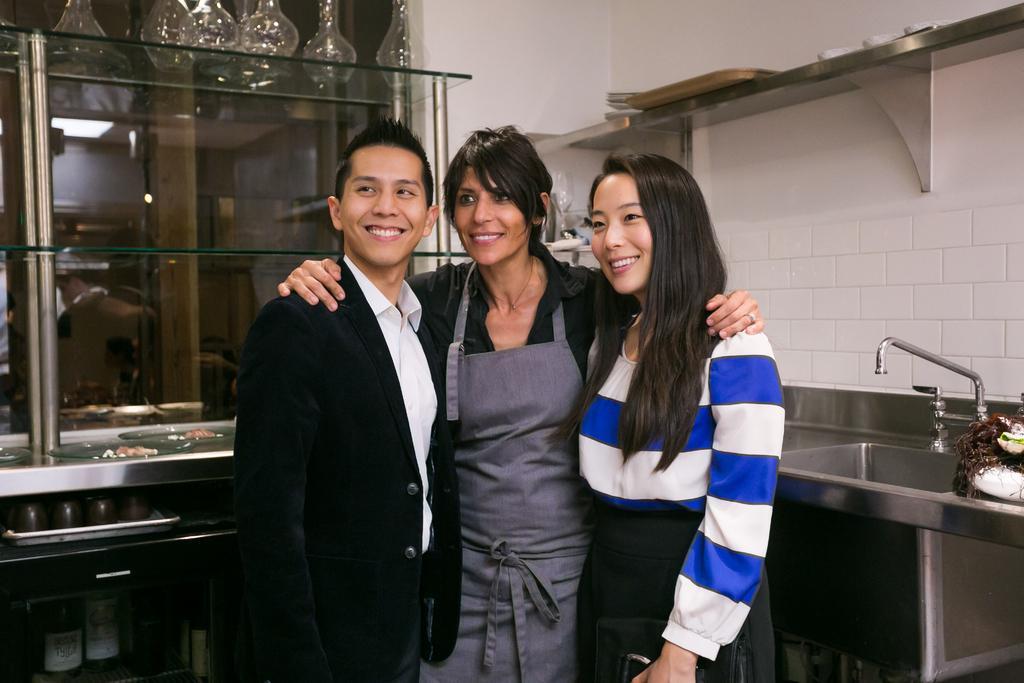Can you describe this image briefly? In this image we can see three people standing and smiling, on the left side, we can see a sink and some objects on the shelf, in the background, we can see some objects on the glass and in the racks we can see some bottles, cups and a tray. 